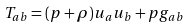Convert formula to latex. <formula><loc_0><loc_0><loc_500><loc_500>T _ { a b } = ( p + \rho ) u _ { a } u _ { b } + p g _ { a b }</formula> 